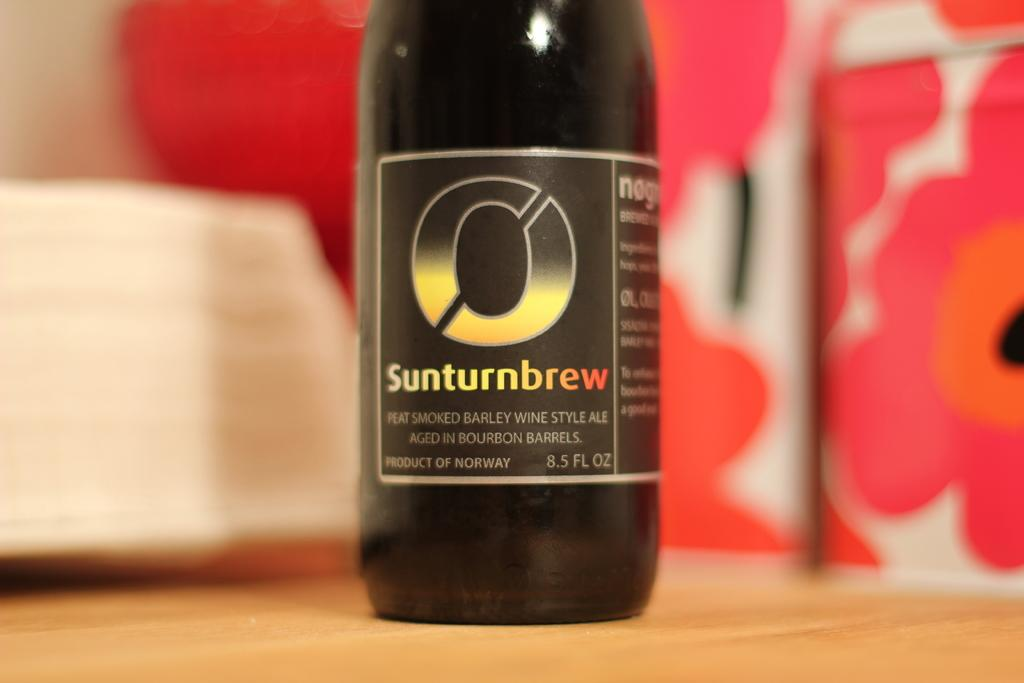<image>
Present a compact description of the photo's key features. A bottle of ale with a smoked barley wine style. 